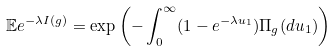<formula> <loc_0><loc_0><loc_500><loc_500>\mathbb { E } e ^ { - \lambda I ( g ) } = \exp \left ( - \int _ { 0 } ^ { \infty } ( 1 - e ^ { - \lambda u _ { 1 } } ) \Pi _ { g } ( d u _ { 1 } ) \right )</formula> 